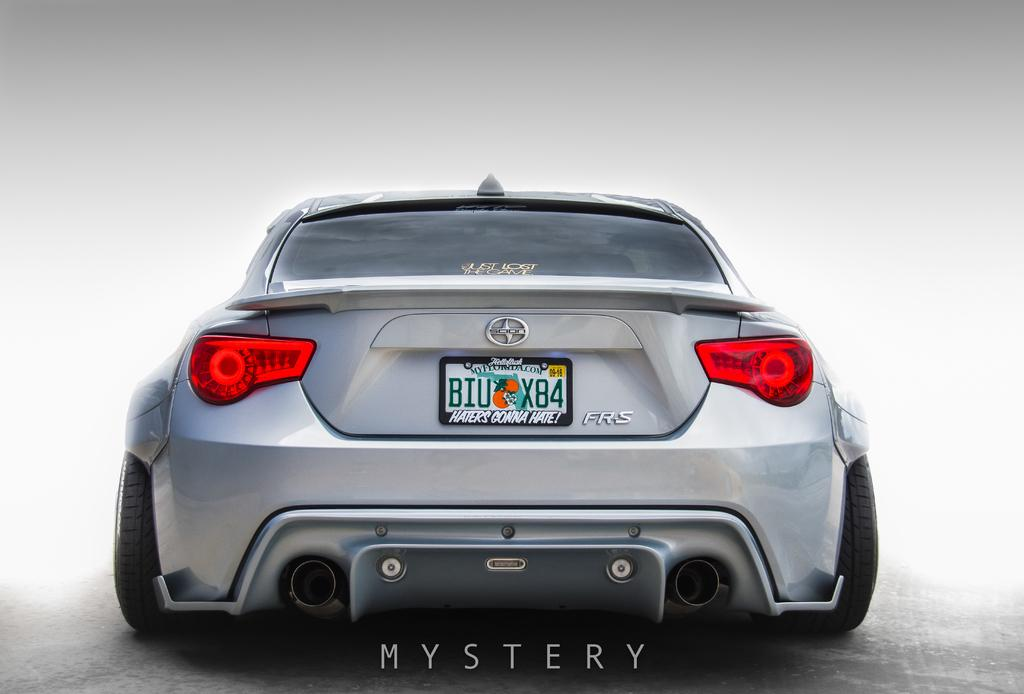What is the main subject of the image? There is a car in the image. From which angle is the car viewed? The car is viewed from the backside. How many sisters are playing with the toy on the island in the image? There is no toy, sisters, or island present in the image; it only features a car viewed from the backside. 